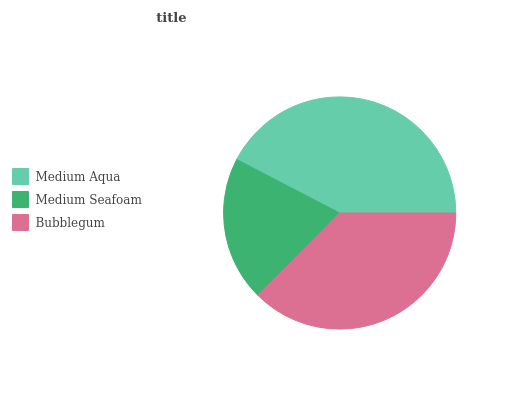Is Medium Seafoam the minimum?
Answer yes or no. Yes. Is Medium Aqua the maximum?
Answer yes or no. Yes. Is Bubblegum the minimum?
Answer yes or no. No. Is Bubblegum the maximum?
Answer yes or no. No. Is Bubblegum greater than Medium Seafoam?
Answer yes or no. Yes. Is Medium Seafoam less than Bubblegum?
Answer yes or no. Yes. Is Medium Seafoam greater than Bubblegum?
Answer yes or no. No. Is Bubblegum less than Medium Seafoam?
Answer yes or no. No. Is Bubblegum the high median?
Answer yes or no. Yes. Is Bubblegum the low median?
Answer yes or no. Yes. Is Medium Seafoam the high median?
Answer yes or no. No. Is Medium Aqua the low median?
Answer yes or no. No. 